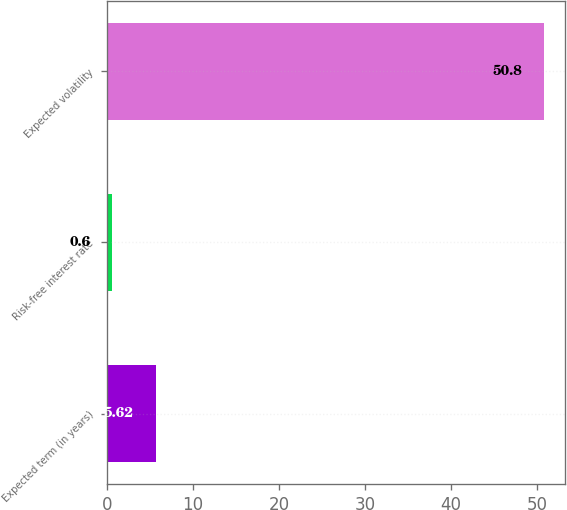Convert chart. <chart><loc_0><loc_0><loc_500><loc_500><bar_chart><fcel>Expected term (in years)<fcel>Risk-free interest rate<fcel>Expected volatility<nl><fcel>5.62<fcel>0.6<fcel>50.8<nl></chart> 